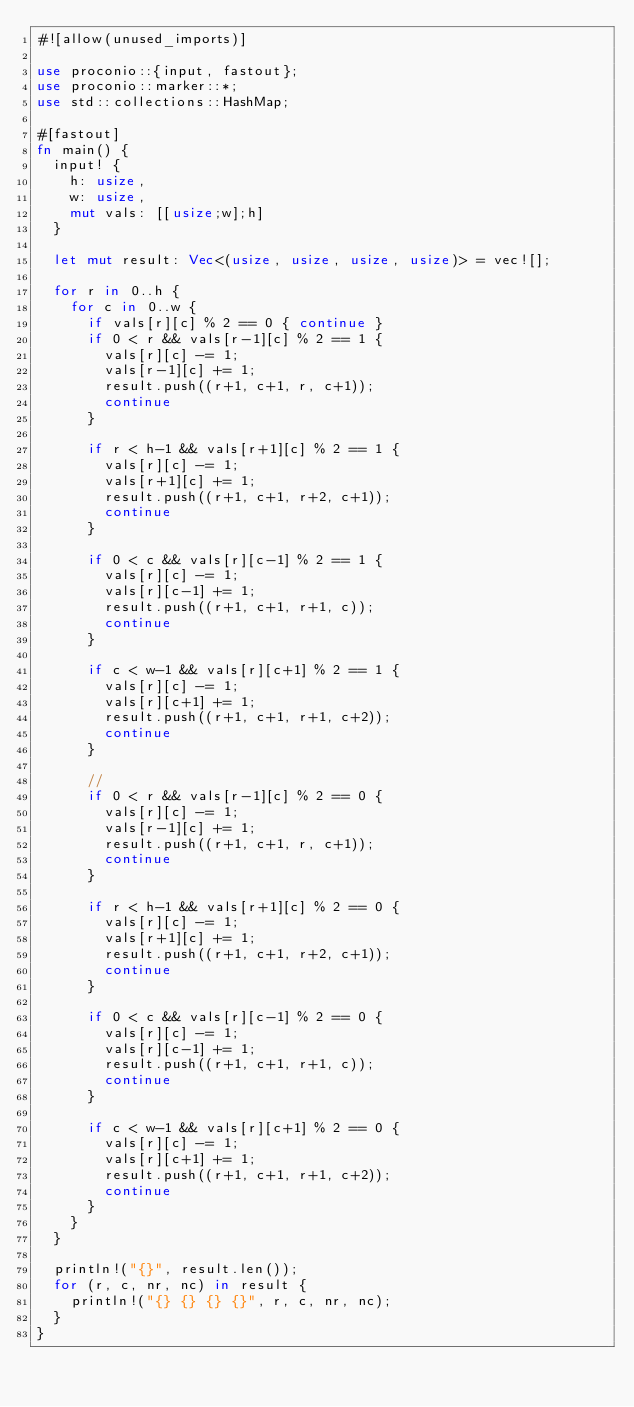<code> <loc_0><loc_0><loc_500><loc_500><_Rust_>#![allow(unused_imports)]
 
use proconio::{input, fastout};
use proconio::marker::*;
use std::collections::HashMap;

#[fastout]
fn main() {
  input! {
    h: usize,
    w: usize,
    mut vals: [[usize;w];h]
  }
  
  let mut result: Vec<(usize, usize, usize, usize)> = vec![];
  
  for r in 0..h {
    for c in 0..w {
      if vals[r][c] % 2 == 0 { continue }
      if 0 < r && vals[r-1][c] % 2 == 1 {
        vals[r][c] -= 1;
        vals[r-1][c] += 1;
        result.push((r+1, c+1, r, c+1));
        continue
      }
      
      if r < h-1 && vals[r+1][c] % 2 == 1 {
        vals[r][c] -= 1;
        vals[r+1][c] += 1;
        result.push((r+1, c+1, r+2, c+1));
        continue
      }
      
      if 0 < c && vals[r][c-1] % 2 == 1 {
        vals[r][c] -= 1;
        vals[r][c-1] += 1;
        result.push((r+1, c+1, r+1, c));
        continue
      }
      
      if c < w-1 && vals[r][c+1] % 2 == 1 {
        vals[r][c] -= 1;
        vals[r][c+1] += 1;
        result.push((r+1, c+1, r+1, c+2));
        continue
      }
      
      // 
      if 0 < r && vals[r-1][c] % 2 == 0 {
        vals[r][c] -= 1;
        vals[r-1][c] += 1;
        result.push((r+1, c+1, r, c+1));
        continue
      }
      
      if r < h-1 && vals[r+1][c] % 2 == 0 {
        vals[r][c] -= 1;
        vals[r+1][c] += 1;
        result.push((r+1, c+1, r+2, c+1));
        continue
      }
      
      if 0 < c && vals[r][c-1] % 2 == 0 {
        vals[r][c] -= 1;
        vals[r][c-1] += 1;
        result.push((r+1, c+1, r+1, c));
        continue
      }
      
      if c < w-1 && vals[r][c+1] % 2 == 0 {
        vals[r][c] -= 1;
        vals[r][c+1] += 1;
        result.push((r+1, c+1, r+1, c+2));
        continue
      }
    }
  }

  println!("{}", result.len());
  for (r, c, nr, nc) in result {
    println!("{} {} {} {}", r, c, nr, nc);
  }
}</code> 